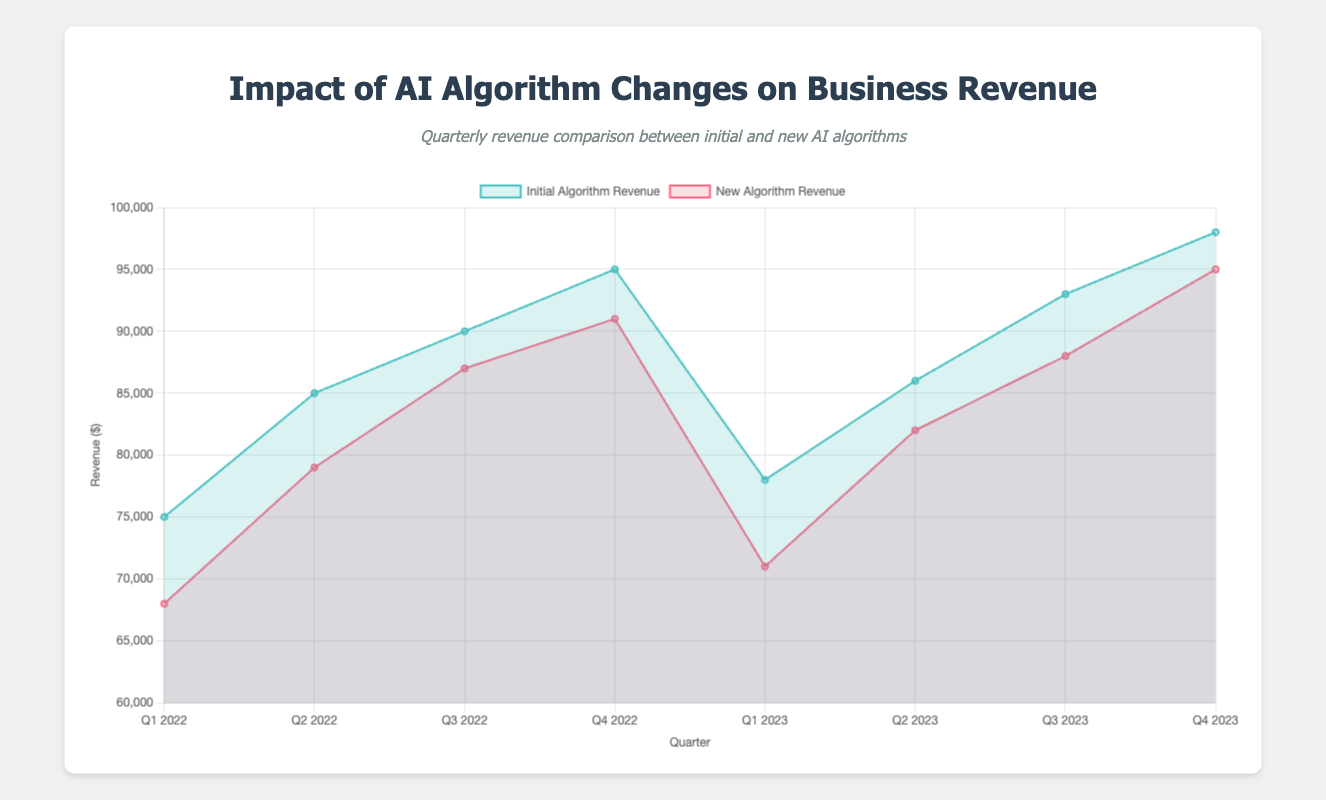What's the title of the chart? The title of the chart appears at the top and should clearly state the main focus of the chart which is the "Impact of AI Algorithm Changes on Business Revenue."
Answer: Impact of AI Algorithm Changes on Business Revenue How does the new algorithm's revenue for Online Retailer A change from Q1 2022 to Q2 2022? For Online Retailer A, in Q1 2022, the new algorithm revenue was $68,000, and in Q2 2022, it was $79,000. The change can be calculated as $79,000 - $68,000.
Answer: Increases by $11,000 Between which quarters does Online Retailer A experience the smallest revenue drop when using the new algorithm? Comparing the differences between the new and initial algorithms across the quarters for Online Retailer A, we look for the quarter pair with the smallest difference. Q3 2022 and Q4 2022 both have smaller differences but Q3 2022 to Q4 2022 has the smallest at $4,000.
Answer: Q3 2022 to Q4 2022 Which company had the highest revenue with the initial algorithm in Q4 2023? Look at the revenue data for Q4 2023 for all companies. Fintech Company B with $98,000 had the highest revenue among the initial algorithm.
Answer: Fintech Company B What's the average revenue difference between the initial and new algorithms for E-commerce Platform C over all the quarters? For E-commerce Platform C:
- Q1 2022: $72,000 - $68,000 = $4,000
- Q2 2022: $81,000 - $78,000 = $3,000
- Q3 2022: $86,000 - $83,000 = $3,000
- Q4 2022: $89,000 - $87,000 = $2,000
Sum the differences: $4,000 + $3,000 + $3,000 + $2,000 = $12,000. Average difference: $12,000 / 4 = $3,000.
Answer: $3,000 During which quarter does the new algorithm revenue for Fintech Company B first surpass $90,000? Observing the new algorithm revenue for Fintech Company B, the value first surpasses $90,000 in Q4 2023 with $95,000.
Answer: Q4 2023 By how much did the new algorithm revenue decrease for E-commerce Platform C from Q2 2022 to Q4 2022? For E-commerce Platform C, from $78,000 in Q2 2022 to $87,000 in Q4 2022. The decrease is calculated as $87,000 - $78,000.
Answer: Decreased by $9,000 Which quarter shows the largest revenue gap between the initial and new algorithms across all companies? Comparing quarter-wise differences between initial and new algorithm revenues for all companies, the largest gap is noticed in Q1 2023 for Fintech Company B: $78,000 - $71,000 = $7,000.
Answer: Q1 2023 